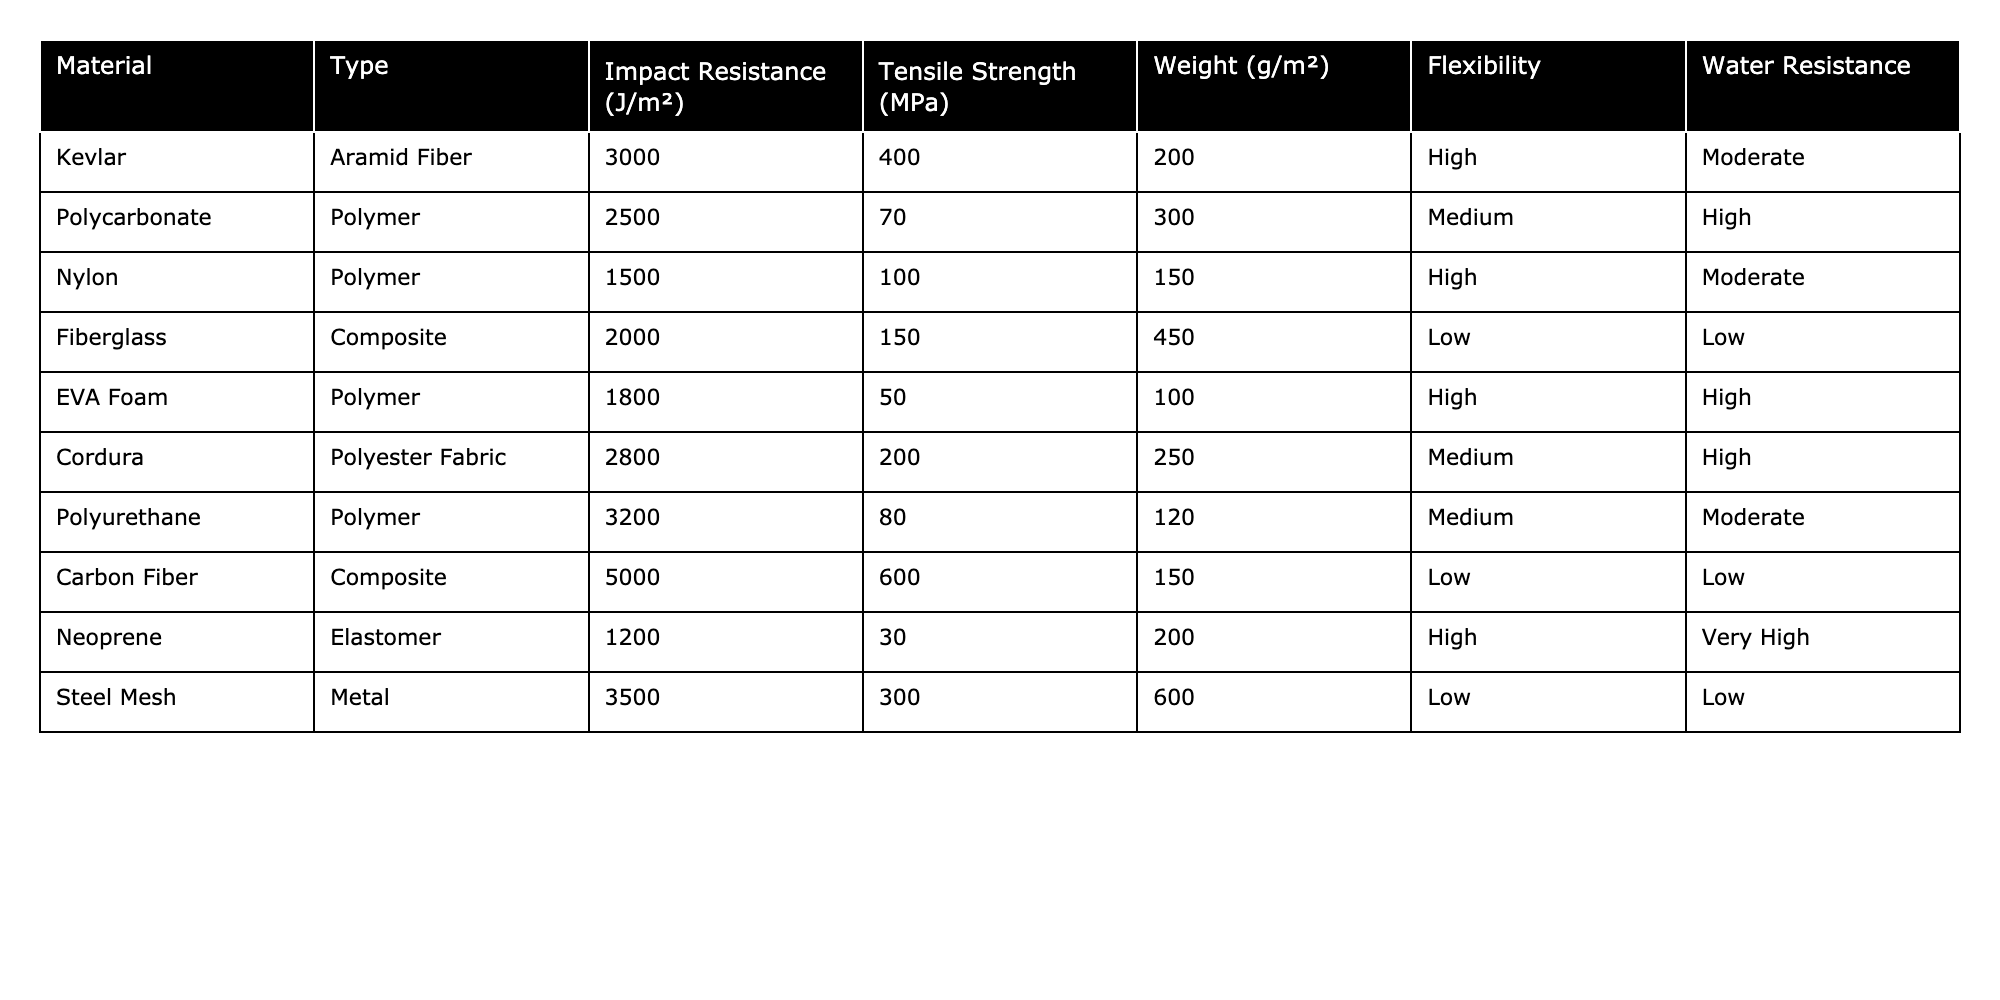What is the impact resistance of Carbon Fiber? The table lists the impact resistance of Carbon Fiber, which is directly provided under the "Impact Resistance" column. It shows a value of 5000 J/m².
Answer: 5000 J/m² Which material has the highest tensile strength? By reviewing the "Tensile Strength" column, we observe that Carbon Fiber has the highest tensile strength at 600 MPa, compared to other materials.
Answer: Carbon Fiber How much does EVA Foam weigh compared to Nylon? The "Weight" column indicates that EVA Foam weighs 100 g/m² and Nylon weighs 150 g/m². The difference in weight is calculated by subtracting 100 from 150, resulting in 50 g/m².
Answer: 50 g/m² Is the Water Resistance of Neoprene classified as high? In the "Water Resistance" column, Neoprene is listed as having "Very High" water resistance, which is indeed a classification higher than high.
Answer: Yes What is the average tensile strength of Polymer materials in the table? We first identify the Polymer materials (Polycarbonate, Nylon, EVA Foam, and Polyurethane) and note their tensile strengths: 70, 100, 50, and 80 MPa, respectively. The sum is 300 MPa, and with 4 materials, the average is calculated as 300/4 = 75 MPa.
Answer: 75 MPa Which materials have high flexibility and moderate water resistance? The "Flexibility" and "Water Resistance" columns are checked. The only material that meets both criteria of high flexibility and moderate water resistance is Nylon.
Answer: Nylon If we rank materials by impact resistance, what is the third material on the list? By ordering the impact resistance values from highest to lowest (Carbon Fiber, Polyurethane, Steel Mesh, Kevlar, Cordura, Polycarbonate, Fiberglass, Nylon, EVA Foam, Neoprene), the third material is identified as Steel Mesh.
Answer: Steel Mesh What is the difference between the impact resistance of Kevlar and Polycarbonate? We look at the "Impact Resistance" values: Kevlar has 3000 J/m² and Polycarbonate has 2500 J/m². The difference is calculated by subtracting 2500 from 3000, resulting in 500 J/m².
Answer: 500 J/m² Are there any materials that exhibit low flexibility? The "Flexibility" column is examined for classifications of low flexibility. Both Fiberglass and Carbon Fiber are classified as having low flexibility.
Answer: Yes Sort the materials by weight and identify the lightest material. We consult the "Weight" column, noting the weights: EVA Foam (100 g/m²), Nylon (150 g/m²), Cordura (250 g/m²), Polycarbonate (300 g/m²), Aramid Fiber (200 g/m²), and Fiberglass (450 g/m²). Upon sorting, the lightest material is EVA Foam at 100 g/m².
Answer: EVA Foam 